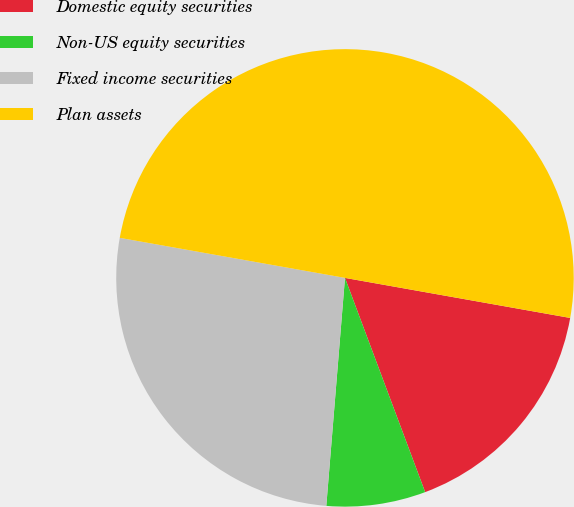Convert chart. <chart><loc_0><loc_0><loc_500><loc_500><pie_chart><fcel>Domestic equity securities<fcel>Non-US equity securities<fcel>Fixed income securities<fcel>Plan assets<nl><fcel>16.5%<fcel>7.0%<fcel>26.5%<fcel>50.0%<nl></chart> 